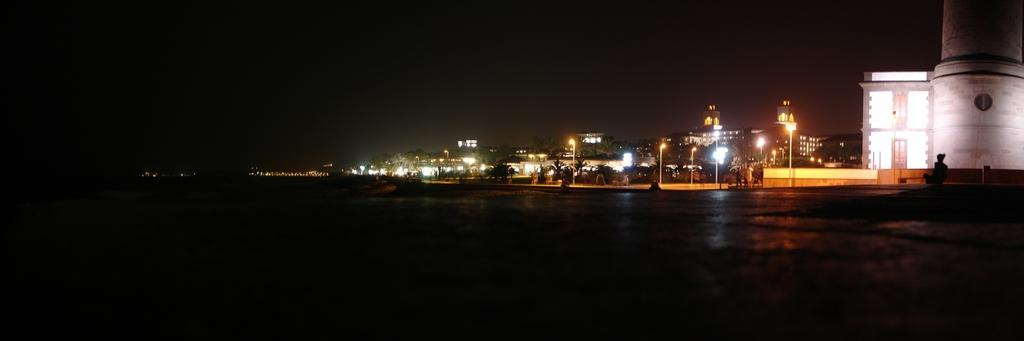What type of structures can be seen in the image? There are buildings, houses, and poles in the image. What other natural elements are present in the image? There are trees in the image. What type of infrastructure is visible in the image? There are lights and a road at the bottom of the image. What is the color of the background in the image? The background of the image is black. Where is the heart-shaped vase located in the image? There is no heart-shaped vase present in the image. 